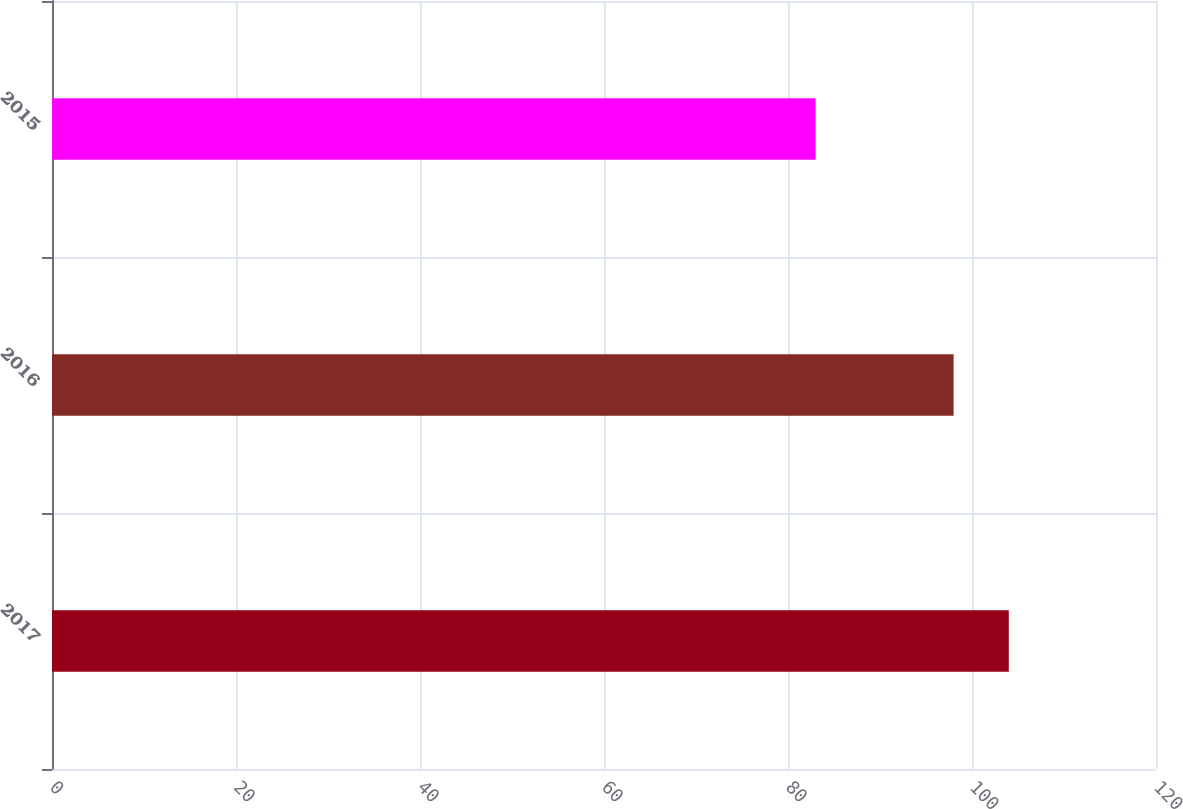<chart> <loc_0><loc_0><loc_500><loc_500><bar_chart><fcel>2017<fcel>2016<fcel>2015<nl><fcel>104<fcel>98<fcel>83<nl></chart> 